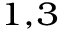<formula> <loc_0><loc_0><loc_500><loc_500>^ { 1 , 3 }</formula> 